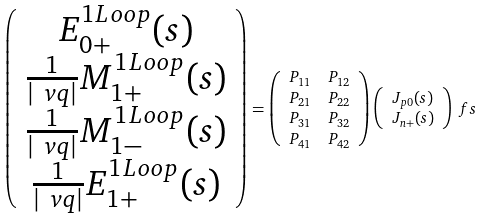Convert formula to latex. <formula><loc_0><loc_0><loc_500><loc_500>\left ( \begin{array} { c } E _ { 0 + } ^ { 1 L o o p } ( s ) \\ \frac { 1 } { | \ v q | } M _ { 1 + } ^ { 1 L o o p } ( s ) \\ \frac { 1 } { | \ v q | } M _ { 1 - } ^ { 1 L o o p } ( s ) \\ \frac { 1 } { | \ v q | } E _ { 1 + } ^ { 1 L o o p } ( s ) \end{array} \right ) & = \left ( \begin{array} { c c } P _ { 1 1 } & P _ { 1 2 } \\ P _ { 2 1 } & P _ { 2 2 } \\ P _ { 3 1 } & P _ { 3 2 } \\ P _ { 4 1 } & P _ { 4 2 } \end{array} \right ) \left ( \begin{array} { c } J _ { p 0 } ( s ) \\ J _ { n + } ( s ) \end{array} \right ) \ f s</formula> 